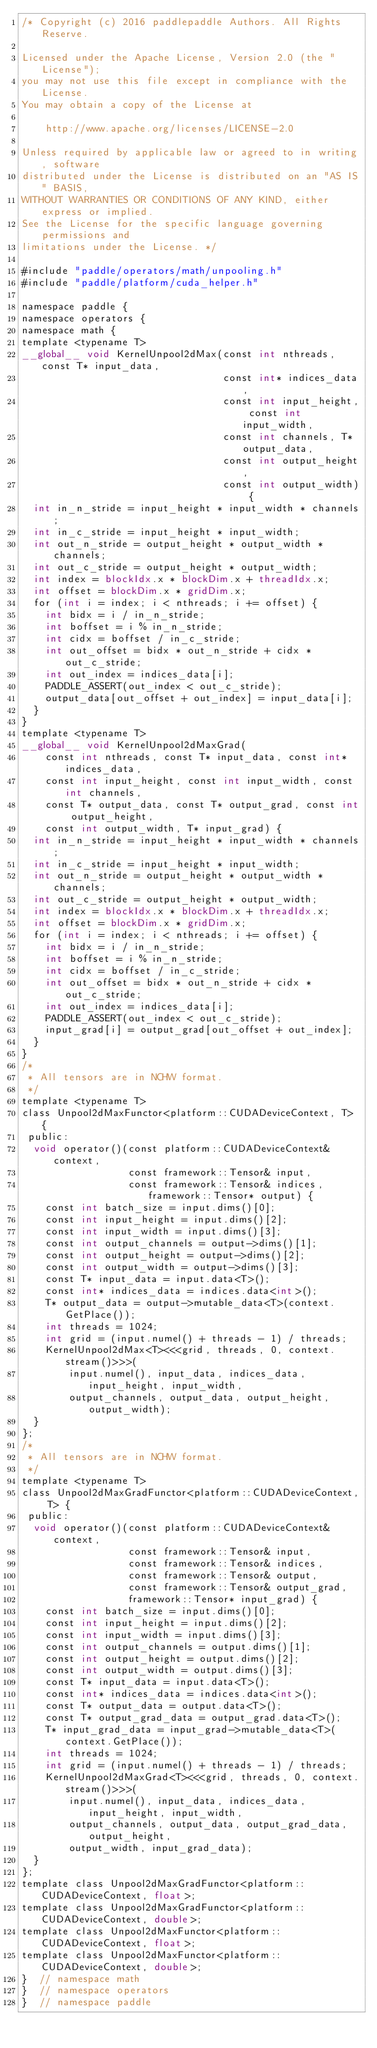<code> <loc_0><loc_0><loc_500><loc_500><_Cuda_>/* Copyright (c) 2016 paddlepaddle Authors. All Rights Reserve.

Licensed under the Apache License, Version 2.0 (the "License");
you may not use this file except in compliance with the License.
You may obtain a copy of the License at

    http://www.apache.org/licenses/LICENSE-2.0

Unless required by applicable law or agreed to in writing, software
distributed under the License is distributed on an "AS IS" BASIS,
WITHOUT WARRANTIES OR CONDITIONS OF ANY KIND, either express or implied.
See the License for the specific language governing permissions and
limitations under the License. */

#include "paddle/operators/math/unpooling.h"
#include "paddle/platform/cuda_helper.h"

namespace paddle {
namespace operators {
namespace math {
template <typename T>
__global__ void KernelUnpool2dMax(const int nthreads, const T* input_data,
                                  const int* indices_data,
                                  const int input_height, const int input_width,
                                  const int channels, T* output_data,
                                  const int output_height,
                                  const int output_width) {
  int in_n_stride = input_height * input_width * channels;
  int in_c_stride = input_height * input_width;
  int out_n_stride = output_height * output_width * channels;
  int out_c_stride = output_height * output_width;
  int index = blockIdx.x * blockDim.x + threadIdx.x;
  int offset = blockDim.x * gridDim.x;
  for (int i = index; i < nthreads; i += offset) {
    int bidx = i / in_n_stride;
    int boffset = i % in_n_stride;
    int cidx = boffset / in_c_stride;
    int out_offset = bidx * out_n_stride + cidx * out_c_stride;
    int out_index = indices_data[i];
    PADDLE_ASSERT(out_index < out_c_stride);
    output_data[out_offset + out_index] = input_data[i];
  }
}
template <typename T>
__global__ void KernelUnpool2dMaxGrad(
    const int nthreads, const T* input_data, const int* indices_data,
    const int input_height, const int input_width, const int channels,
    const T* output_data, const T* output_grad, const int output_height,
    const int output_width, T* input_grad) {
  int in_n_stride = input_height * input_width * channels;
  int in_c_stride = input_height * input_width;
  int out_n_stride = output_height * output_width * channels;
  int out_c_stride = output_height * output_width;
  int index = blockIdx.x * blockDim.x + threadIdx.x;
  int offset = blockDim.x * gridDim.x;
  for (int i = index; i < nthreads; i += offset) {
    int bidx = i / in_n_stride;
    int boffset = i % in_n_stride;
    int cidx = boffset / in_c_stride;
    int out_offset = bidx * out_n_stride + cidx * out_c_stride;
    int out_index = indices_data[i];
    PADDLE_ASSERT(out_index < out_c_stride);
    input_grad[i] = output_grad[out_offset + out_index];
  }
}
/*
 * All tensors are in NCHW format.
 */
template <typename T>
class Unpool2dMaxFunctor<platform::CUDADeviceContext, T> {
 public:
  void operator()(const platform::CUDADeviceContext& context,
                  const framework::Tensor& input,
                  const framework::Tensor& indices, framework::Tensor* output) {
    const int batch_size = input.dims()[0];
    const int input_height = input.dims()[2];
    const int input_width = input.dims()[3];
    const int output_channels = output->dims()[1];
    const int output_height = output->dims()[2];
    const int output_width = output->dims()[3];
    const T* input_data = input.data<T>();
    const int* indices_data = indices.data<int>();
    T* output_data = output->mutable_data<T>(context.GetPlace());
    int threads = 1024;
    int grid = (input.numel() + threads - 1) / threads;
    KernelUnpool2dMax<T><<<grid, threads, 0, context.stream()>>>(
        input.numel(), input_data, indices_data, input_height, input_width,
        output_channels, output_data, output_height, output_width);
  }
};
/*
 * All tensors are in NCHW format.
 */
template <typename T>
class Unpool2dMaxGradFunctor<platform::CUDADeviceContext, T> {
 public:
  void operator()(const platform::CUDADeviceContext& context,
                  const framework::Tensor& input,
                  const framework::Tensor& indices,
                  const framework::Tensor& output,
                  const framework::Tensor& output_grad,
                  framework::Tensor* input_grad) {
    const int batch_size = input.dims()[0];
    const int input_height = input.dims()[2];
    const int input_width = input.dims()[3];
    const int output_channels = output.dims()[1];
    const int output_height = output.dims()[2];
    const int output_width = output.dims()[3];
    const T* input_data = input.data<T>();
    const int* indices_data = indices.data<int>();
    const T* output_data = output.data<T>();
    const T* output_grad_data = output_grad.data<T>();
    T* input_grad_data = input_grad->mutable_data<T>(context.GetPlace());
    int threads = 1024;
    int grid = (input.numel() + threads - 1) / threads;
    KernelUnpool2dMaxGrad<T><<<grid, threads, 0, context.stream()>>>(
        input.numel(), input_data, indices_data, input_height, input_width,
        output_channels, output_data, output_grad_data, output_height,
        output_width, input_grad_data);
  }
};
template class Unpool2dMaxGradFunctor<platform::CUDADeviceContext, float>;
template class Unpool2dMaxGradFunctor<platform::CUDADeviceContext, double>;
template class Unpool2dMaxFunctor<platform::CUDADeviceContext, float>;
template class Unpool2dMaxFunctor<platform::CUDADeviceContext, double>;
}  // namespace math
}  // namespace operators
}  // namespace paddle
</code> 